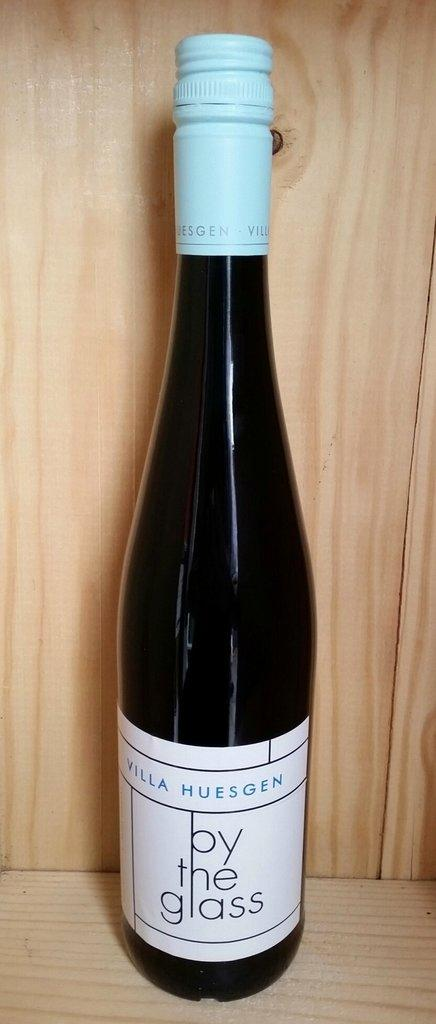<image>
Describe the image concisely. A bottle of Villa Huesgen by the glass wine sits on a wood shelf. 